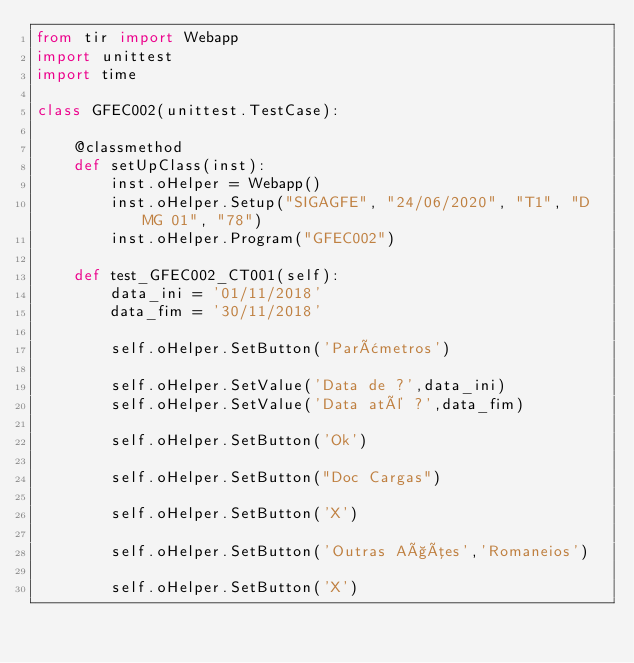<code> <loc_0><loc_0><loc_500><loc_500><_Python_>from tir import Webapp
import unittest
import time

class GFEC002(unittest.TestCase):

    @classmethod
    def setUpClass(inst):
        inst.oHelper = Webapp()
        inst.oHelper.Setup("SIGAGFE", "24/06/2020", "T1", "D MG 01", "78")
        inst.oHelper.Program("GFEC002")

    def test_GFEC002_CT001(self):         
        data_ini = '01/11/2018'
        data_fim = '30/11/2018'

        self.oHelper.SetButton('Parâmetros')

        self.oHelper.SetValue('Data de ?',data_ini)
        self.oHelper.SetValue('Data até ?',data_fim)
        
        self.oHelper.SetButton('Ok')

        self.oHelper.SetButton("Doc Cargas")

        self.oHelper.SetButton('X')

        self.oHelper.SetButton('Outras Ações','Romaneios')

        self.oHelper.SetButton('X')
</code> 